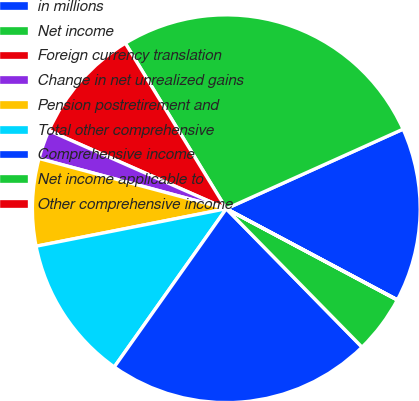Convert chart to OTSL. <chart><loc_0><loc_0><loc_500><loc_500><pie_chart><fcel>in millions<fcel>Net income<fcel>Foreign currency translation<fcel>Change in net unrealized gains<fcel>Pension postretirement and<fcel>Total other comprehensive<fcel>Comprehensive income<fcel>Net income applicable to<fcel>Other comprehensive income<nl><fcel>14.52%<fcel>26.99%<fcel>9.68%<fcel>2.43%<fcel>7.27%<fcel>12.1%<fcel>22.15%<fcel>4.85%<fcel>0.02%<nl></chart> 